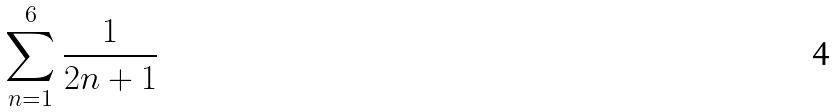<formula> <loc_0><loc_0><loc_500><loc_500>\sum _ { n = 1 } ^ { 6 } \frac { 1 } { 2 n + 1 }</formula> 